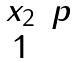<formula> <loc_0><loc_0><loc_500><loc_500>\begin{matrix} x _ { 2 } & p \\ 1 \end{matrix}</formula> 